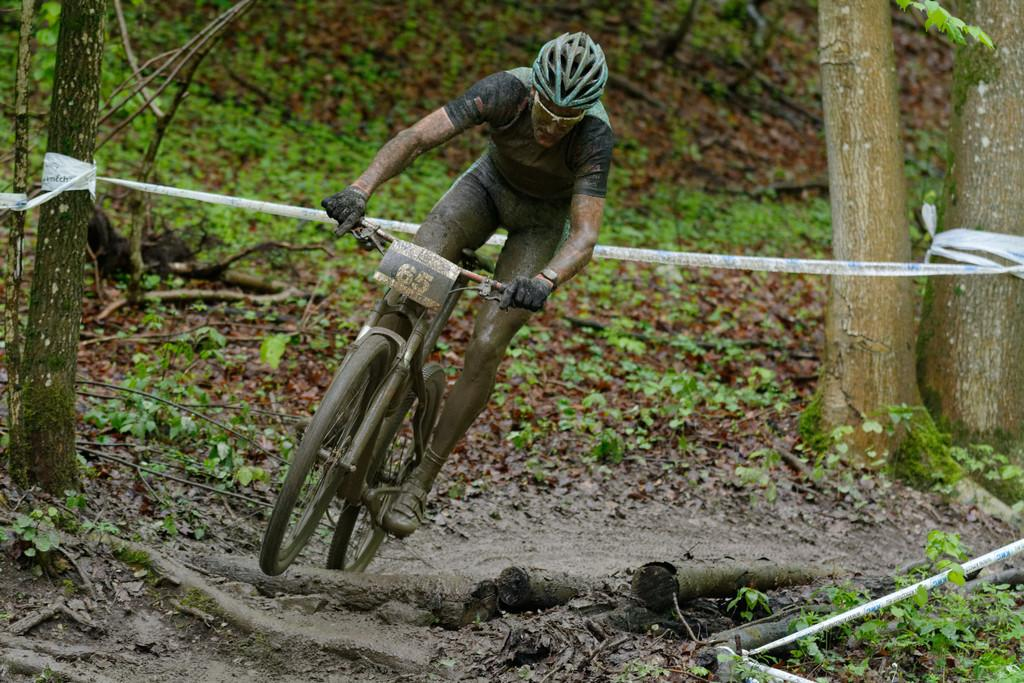What type of terrain is visible in the image? There is grass in the image. Who is present in the image? There is a man in the image. What is the man wearing on his head? The man is wearing a helmet. What activity is the man engaged in? The man is riding a bicycle. What can be seen on the right side of the image? There are tree stems on the right side of the image. What type of oil can be seen dripping from the man's bicycle in the image? There is no oil visible in the image, nor is there any indication that the man's bicycle is leaking oil. 